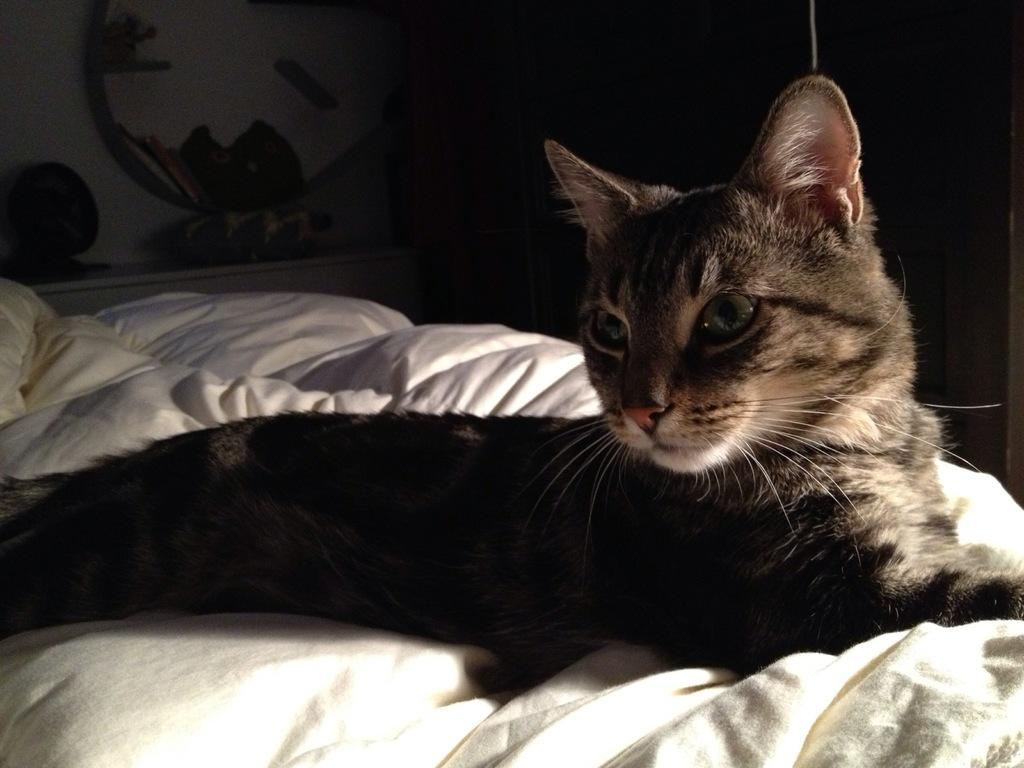What animal can be seen in the image? There is a cat in the image. Where is the cat sitting? The cat is sitting on a couch. What direction is the cat looking? The cat is looking to the side. What is the appearance of the cat's eyes? The cat's eyes are wide open. What is the position of the cat's ears? The cat's ears are erect. What color is the couch the cat is sitting on? The couch is white. How would you describe the lighting or color of the background in the image? The background is dark. What type of ring can be seen on the cat's tail in the image? There is no ring present on the cat's tail in the image. Is there a bomb visible in the image? No, there is no bomb present in the image. 